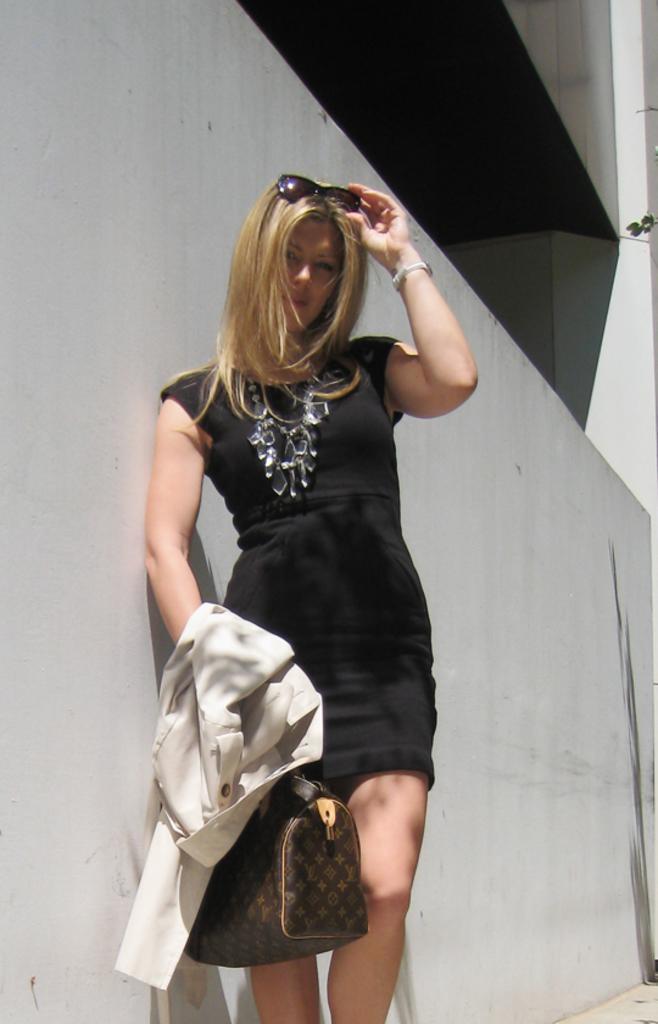Could you give a brief overview of what you see in this image? In this image, there is a lady standing in front of the wall, which is grey in color, whose is wearing a goggle on her head and a black color dress and holding a brown and yellow color bag in her hand. In the background there is a building of grey on color. This image is taken outside during sunny day. 